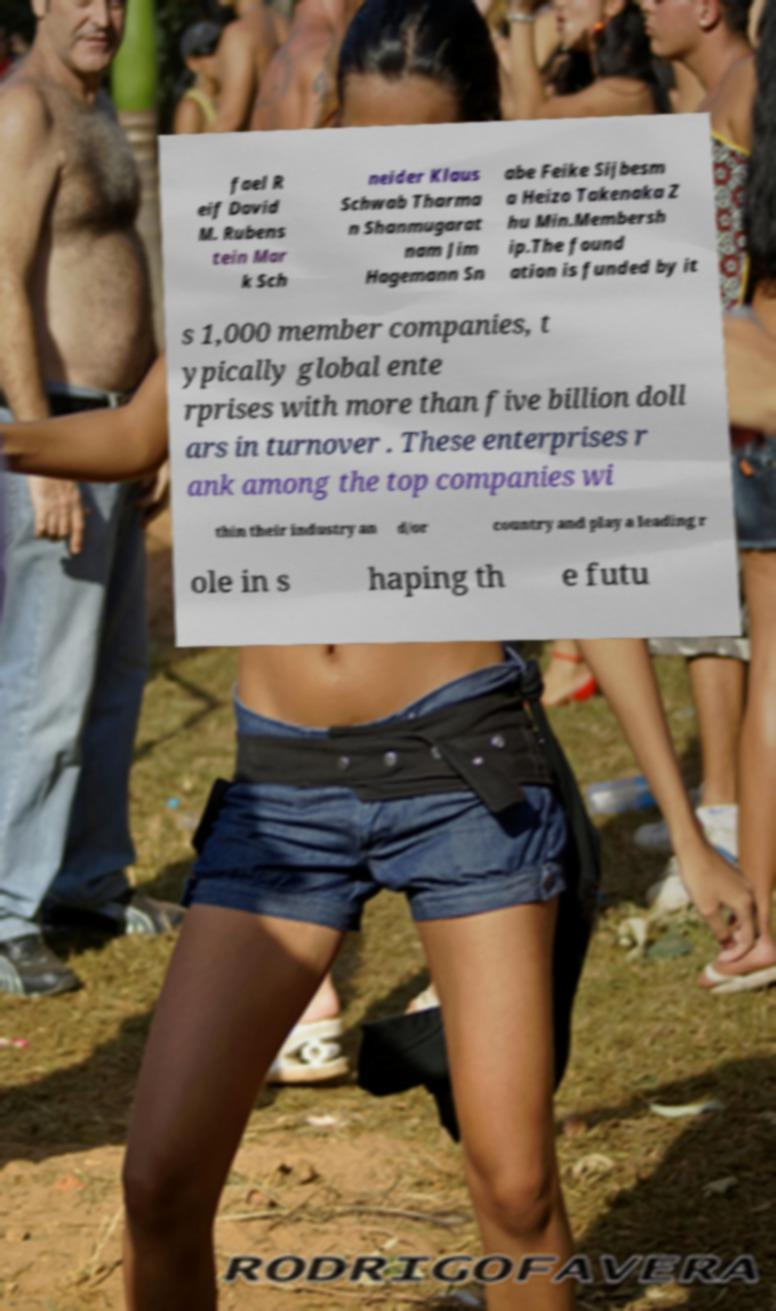Could you extract and type out the text from this image? fael R eif David M. Rubens tein Mar k Sch neider Klaus Schwab Tharma n Shanmugarat nam Jim Hagemann Sn abe Feike Sijbesm a Heizo Takenaka Z hu Min.Membersh ip.The found ation is funded by it s 1,000 member companies, t ypically global ente rprises with more than five billion doll ars in turnover . These enterprises r ank among the top companies wi thin their industry an d/or country and play a leading r ole in s haping th e futu 